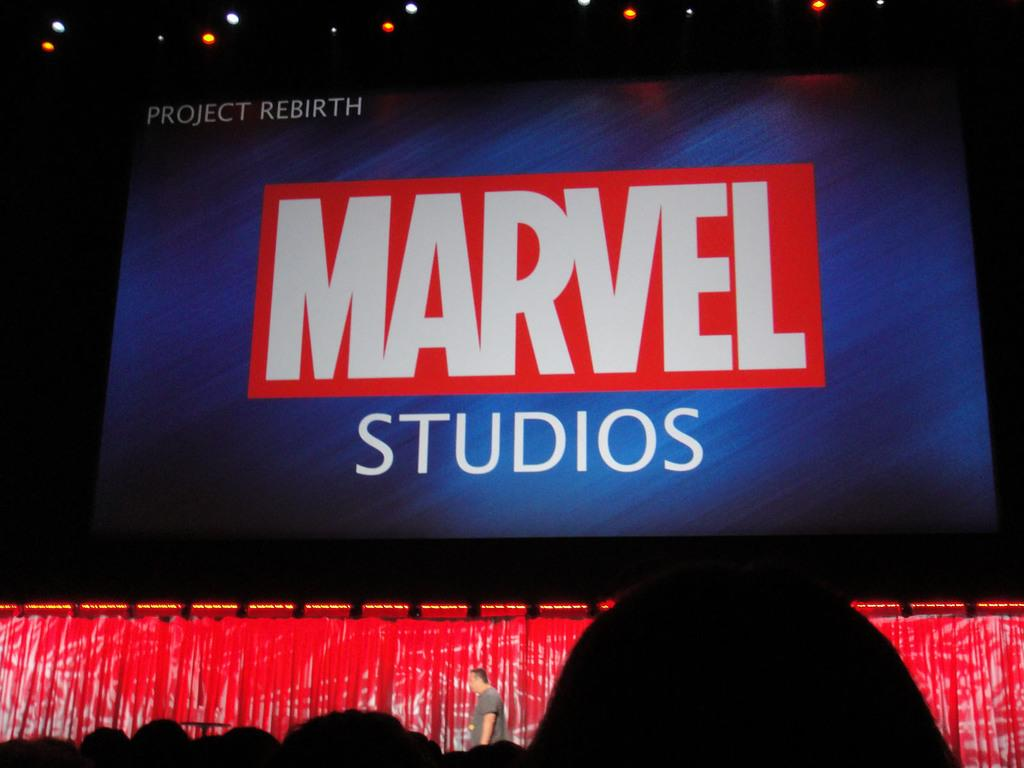What is the main object in the image? There is a big display screen in the image. What is on the display screen? There is text on the display screen. Who is present in the image? There is a man standing below the display screen. What can be seen on the ceiling in the image? There are lights on the ceiling. How would you describe the overall lighting in the image? The background of the image is dark. What type of grape is the man holding in the image? There is no grape present in the image; the man is standing below a display screen with text on it. What book is the man reading in the image? There is no book present in the image; the man is standing below a display screen with text on it. 